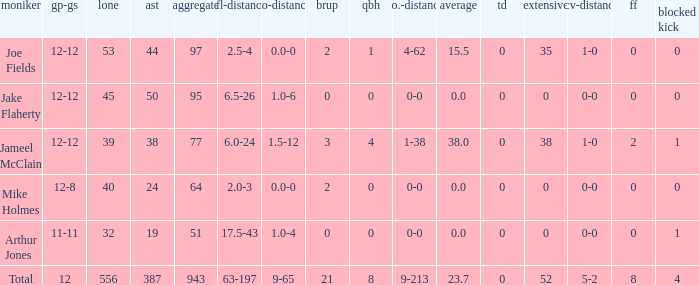How many yards for the player with tfl-yds of 2.5-4? 4-62. 